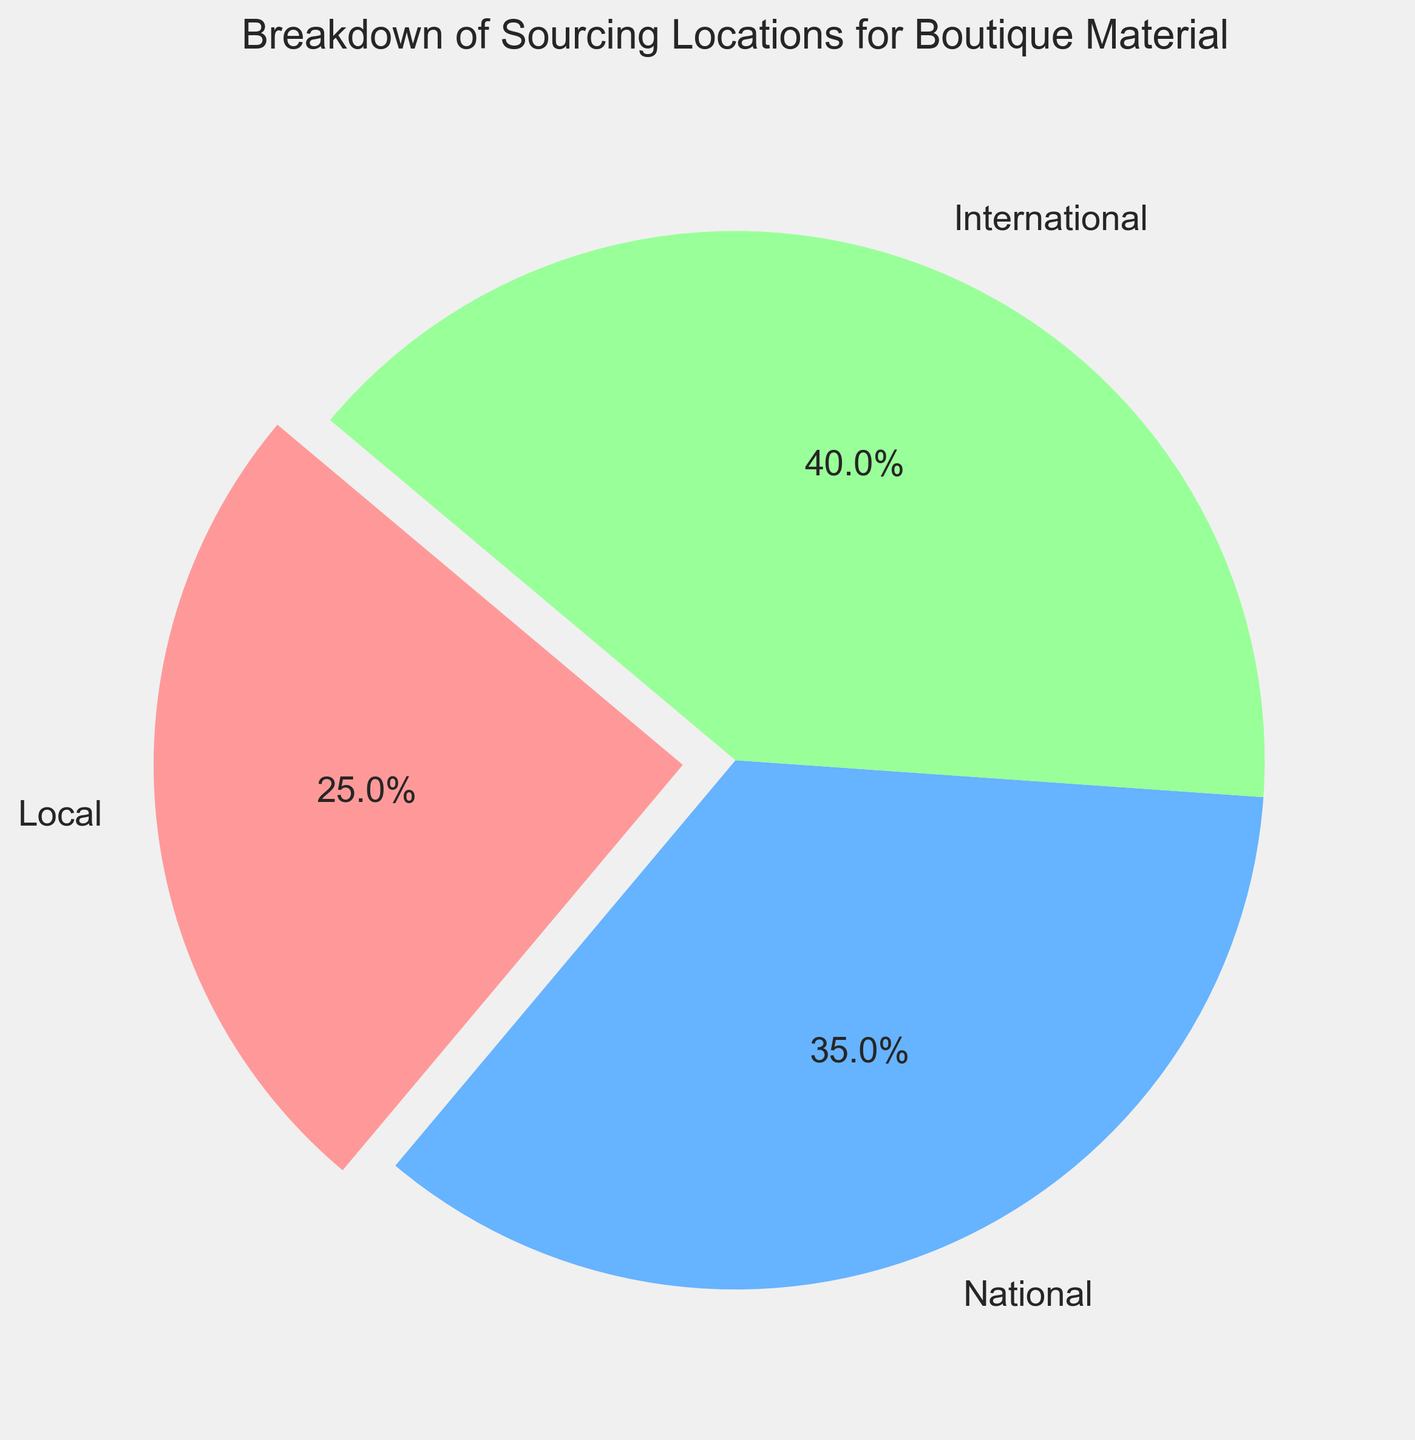What is the percentage of materials sourced locally? The pie chart indicates the percentage values for each sourcing location category. The slice labeled "Local" corresponds to 25%.
Answer: 25% How much more percentage of materials are sourced nationally compared to locally? To find the difference in percentage between national and local sourcing, subtract the local percentage (25%) from the national percentage (35%). Therefore, 35% - 25% = 10%.
Answer: 10% Which sourcing location has the highest percentage of materials? The pie chart shows three sourcing locations: Local, National, and International. The International category has the highest percentage, which is 40%.
Answer: International What is the combined percentage of materials sourced internationally and locally? Add the percentages of materials sourced internationally (40%) and locally (25%). Therefore, 40% + 25% = 65%.
Answer: 65% Describe the color of the slice representing national sourcing. Observing the visual attributes, the slice representing national sourcing is colored blue.
Answer: Blue Is the percentage of materials sourced nationally higher than internationally? By comparing the percentages, the national sourcing percentage is 35%, and the international sourcing percentage is 40%. 35% is less than 40%, so the national percentage is not higher.
Answer: No Which sourcing locations' slices are not exploded in the pie chart? Looking at the visual cues in the pie chart, the slices that are not exploded are for National and International sourcing.
Answer: National and International How much less percentage of materials are sourced locally compared to internationally? Subtract the local sourcing percentage (25%) from the international sourcing percentage (40%). Therefore, 40% - 25% = 15%.
Answer: 15% What is the average percentage of materials sourced from the three locations? To find the average percentage, sum the percentages of materials from all three locations (25% Local, 35% National, 40% International) and divide by 3. Thus, (25 + 35 + 40) / 3 = 100 / 3 ≈ 33.33%.
Answer: 33.33% Which color represents the smallest percentage slice and what percentage does it represent? Observing the colors and sizes, the smallest percentage slice, representing local sourcing (25%), is colored red.
Answer: Red, 25% 